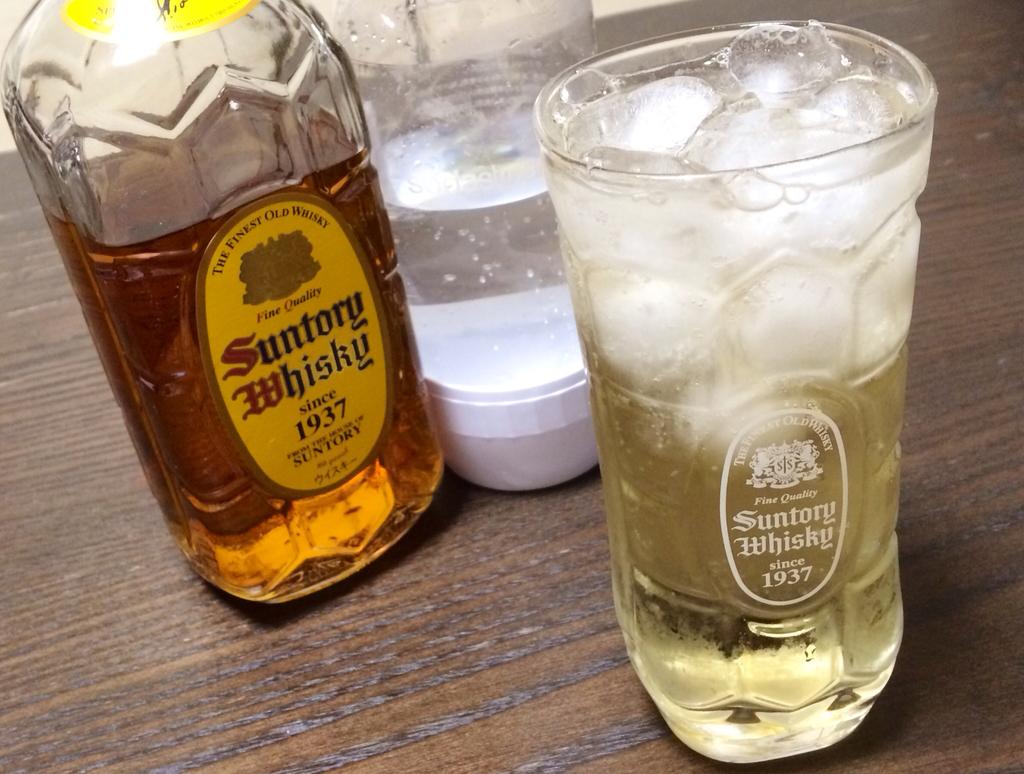What brand is the whisky?
Make the answer very short. Suntory. What year is the whiskey?
Ensure brevity in your answer.  1937. 